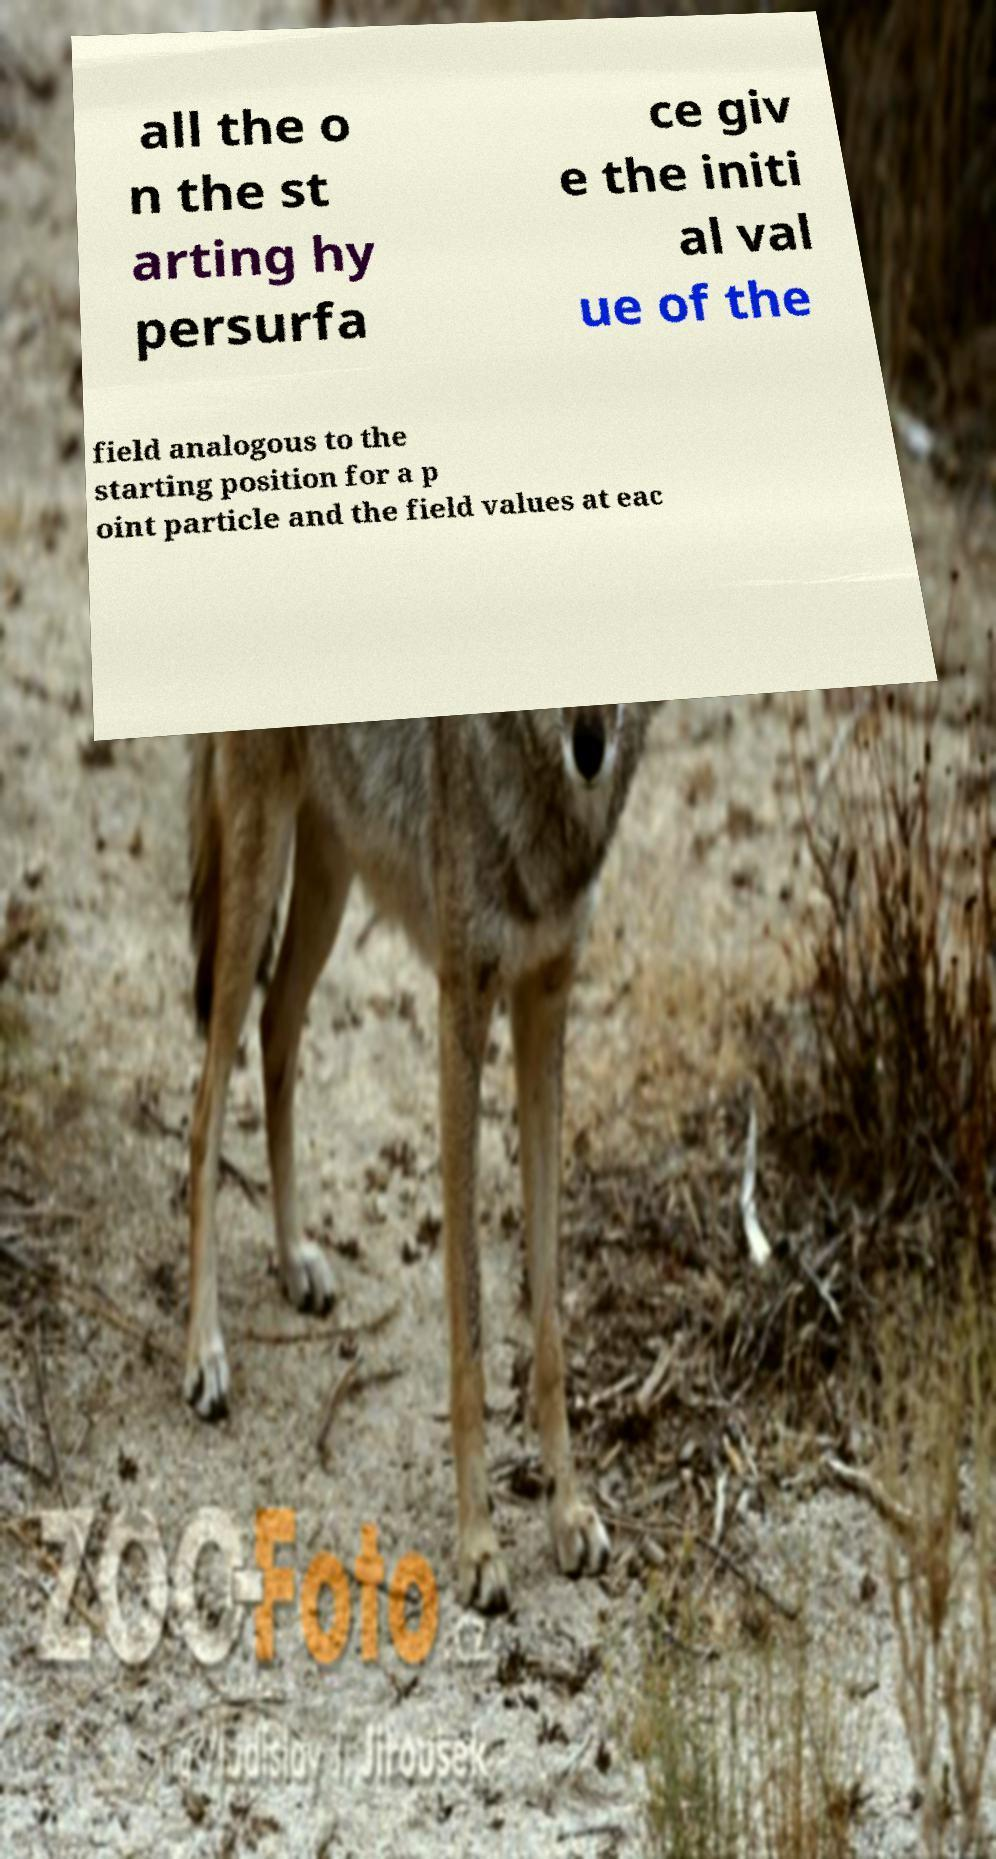I need the written content from this picture converted into text. Can you do that? all the o n the st arting hy persurfa ce giv e the initi al val ue of the field analogous to the starting position for a p oint particle and the field values at eac 